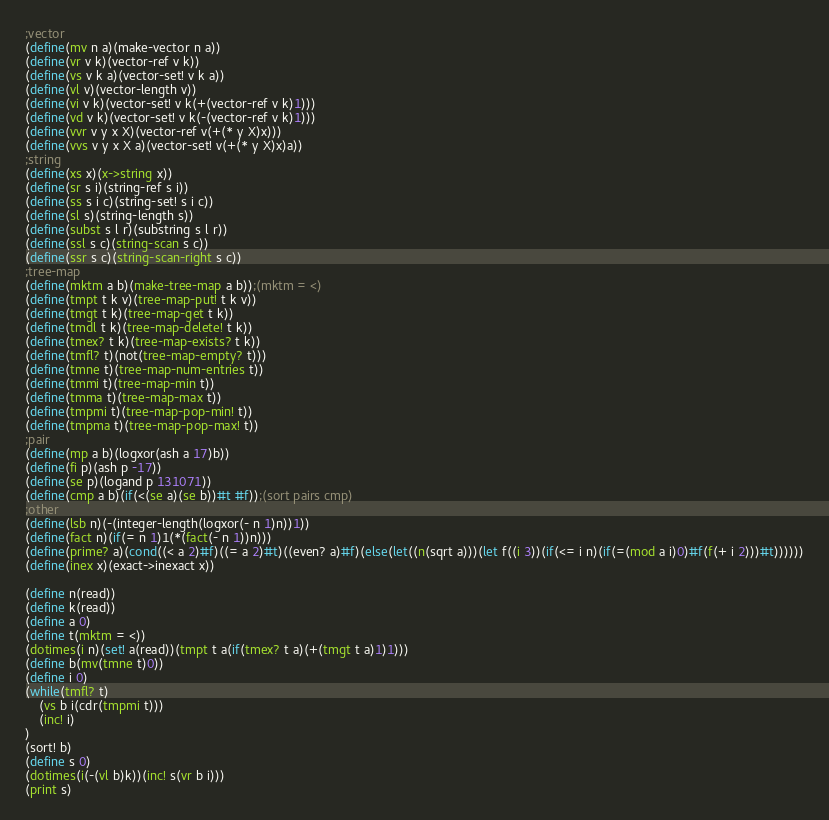Convert code to text. <code><loc_0><loc_0><loc_500><loc_500><_Scheme_>;vector
(define(mv n a)(make-vector n a))
(define(vr v k)(vector-ref v k))
(define(vs v k a)(vector-set! v k a))
(define(vl v)(vector-length v))
(define(vi v k)(vector-set! v k(+(vector-ref v k)1)))
(define(vd v k)(vector-set! v k(-(vector-ref v k)1)))
(define(vvr v y x X)(vector-ref v(+(* y X)x)))
(define(vvs v y x X a)(vector-set! v(+(* y X)x)a))
;string
(define(xs x)(x->string x))
(define(sr s i)(string-ref s i))
(define(ss s i c)(string-set! s i c))
(define(sl s)(string-length s))
(define(subst s l r)(substring s l r))
(define(ssl s c)(string-scan s c))
(define(ssr s c)(string-scan-right s c))
;tree-map
(define(mktm a b)(make-tree-map a b));(mktm = <)
(define(tmpt t k v)(tree-map-put! t k v))
(define(tmgt t k)(tree-map-get t k))
(define(tmdl t k)(tree-map-delete! t k))
(define(tmex? t k)(tree-map-exists? t k))
(define(tmfl? t)(not(tree-map-empty? t)))
(define(tmne t)(tree-map-num-entries t))
(define(tmmi t)(tree-map-min t))
(define(tmma t)(tree-map-max t))
(define(tmpmi t)(tree-map-pop-min! t))
(define(tmpma t)(tree-map-pop-max! t))
;pair
(define(mp a b)(logxor(ash a 17)b))
(define(fi p)(ash p -17))
(define(se p)(logand p 131071))
(define(cmp a b)(if(<(se a)(se b))#t #f));(sort pairs cmp)
;other
(define(lsb n)(-(integer-length(logxor(- n 1)n))1))
(define(fact n)(if(= n 1)1(*(fact(- n 1))n)))
(define(prime? a)(cond((< a 2)#f)((= a 2)#t)((even? a)#f)(else(let((n(sqrt a)))(let f((i 3))(if(<= i n)(if(=(mod a i)0)#f(f(+ i 2)))#t))))))
(define(inex x)(exact->inexact x))

(define n(read))
(define k(read))
(define a 0)
(define t(mktm = <))
(dotimes(i n)(set! a(read))(tmpt t a(if(tmex? t a)(+(tmgt t a)1)1)))
(define b(mv(tmne t)0))
(define i 0)
(while(tmfl? t)
	(vs b i(cdr(tmpmi t)))
	(inc! i)
)
(sort! b)
(define s 0)
(dotimes(i(-(vl b)k))(inc! s(vr b i)))
(print s)</code> 